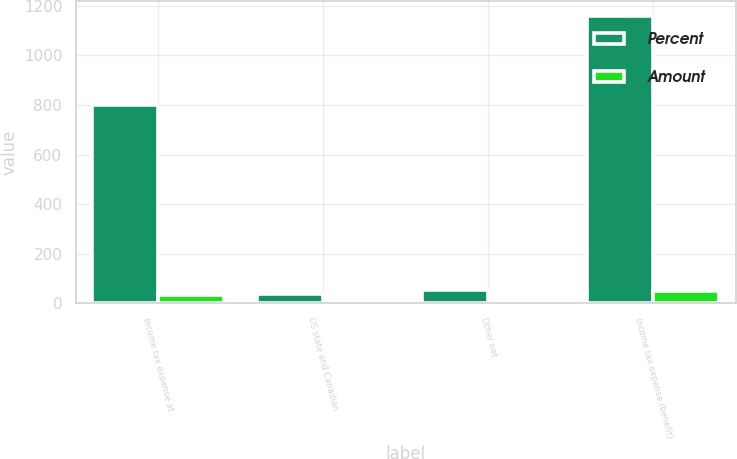<chart> <loc_0><loc_0><loc_500><loc_500><stacked_bar_chart><ecel><fcel>Income tax expense at<fcel>US state and Canadian<fcel>Other net<fcel>Income tax expense (benefit)<nl><fcel>Percent<fcel>799<fcel>37<fcel>52<fcel>1160<nl><fcel>Amount<fcel>35<fcel>1.6<fcel>2.3<fcel>50.9<nl></chart> 